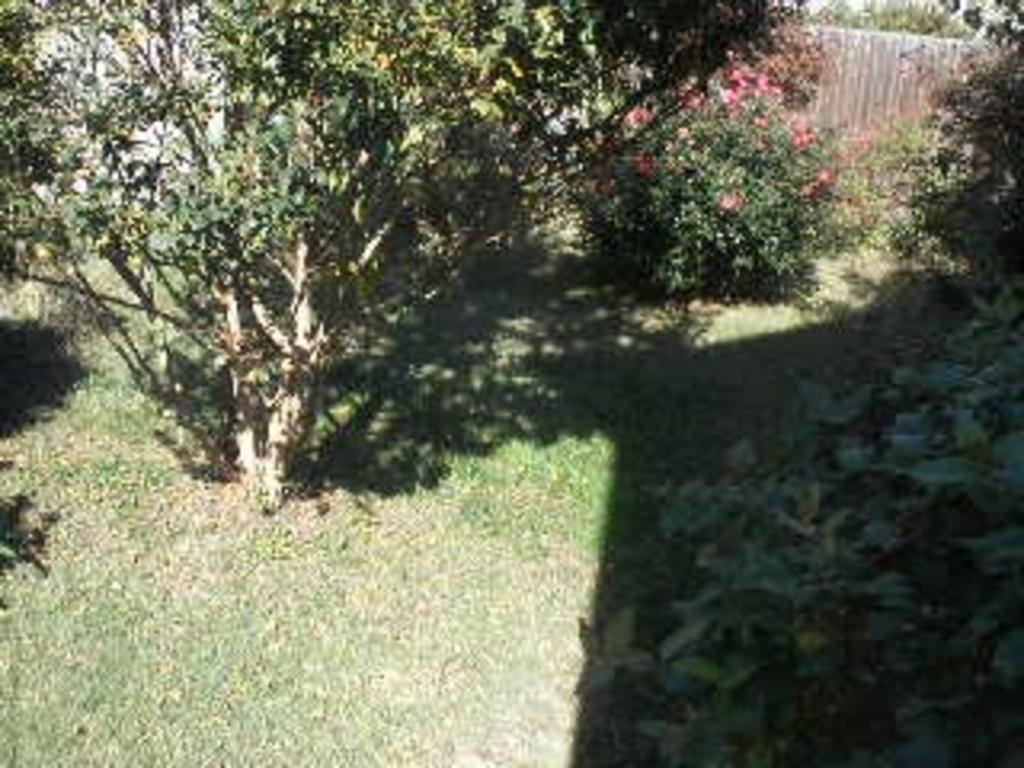What type of surface can be seen in the image? The ground is visible in the image. What type of vegetation is present in the image? There is grass, plants, and trees in the image. Can you describe the background of the image? There is an unspecified object in the background of the image. What type of root can be seen growing from the vase in the image? There is no vase present in the image, and therefore no roots can be seen growing from it. 